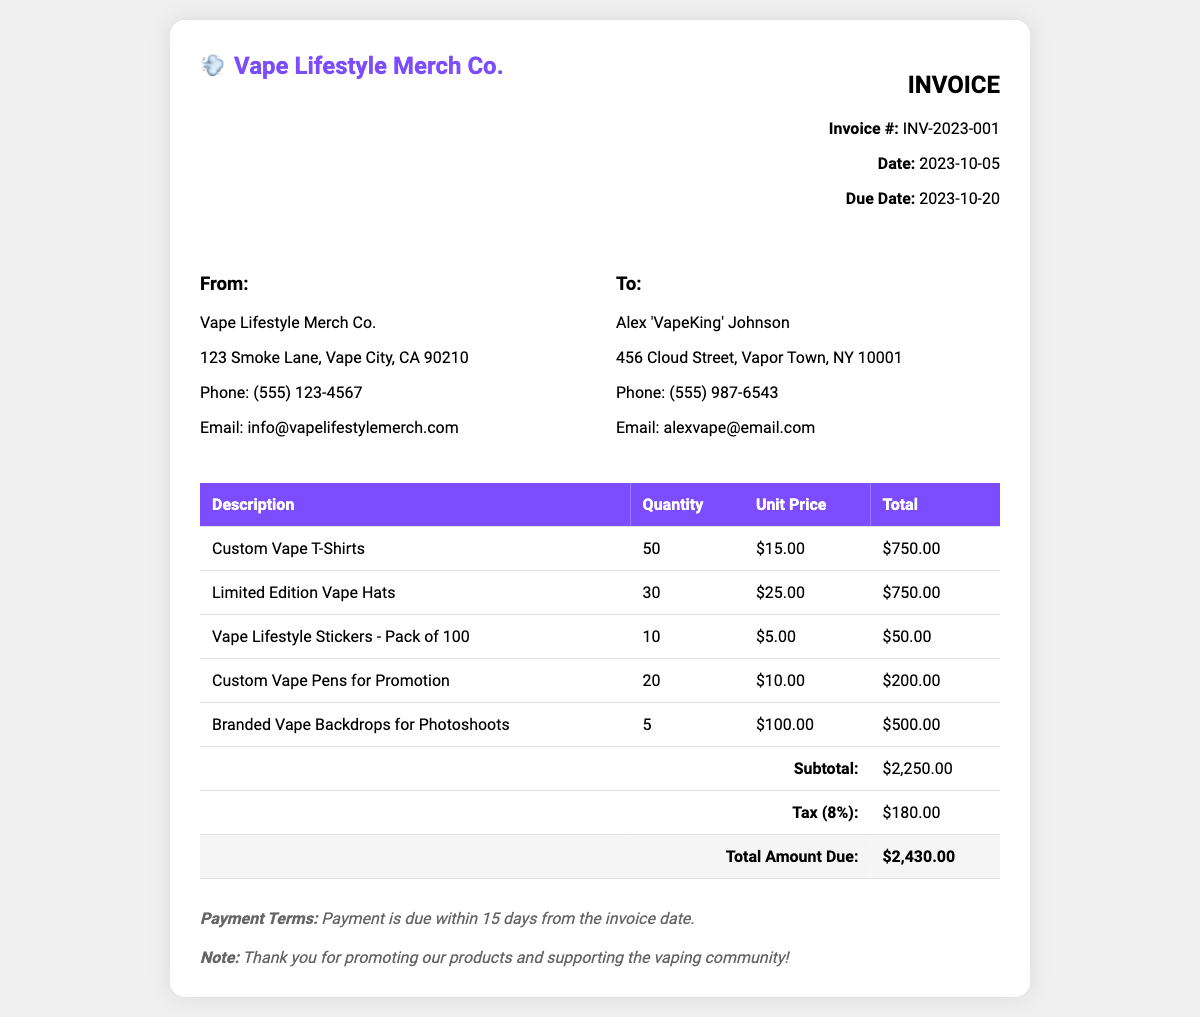What is the invoice number? The invoice number is specified at the top of the document, identified as INV-2023-001.
Answer: INV-2023-001 What is the subtotal amount? The subtotal amount is listed in the total section of the document, which shows $2,250.00.
Answer: $2,250.00 How many Custom Vape T-Shirts were ordered? The number of Custom Vape T-Shirts is found in the quantity column for that item, which shows 50.
Answer: 50 Who is the invoice addressed to? The recipient's name is located in the "To" section of the document, which identifies Alex 'VapeKing' Johnson.
Answer: Alex 'VapeKing' Johnson What is the total amount due? The total amount due can be found at the bottom of the invoice, which is stated as $2,430.00.
Answer: $2,430.00 What is the tax percentage applied? The tax percentage can be deduced from the tax amount in the document, which indicates an 8% rate.
Answer: 8% How many Limited Edition Vape Hats were ordered? The quantity of Limited Edition Vape Hats is presented in the table, which shows 30.
Answer: 30 What is the deadline for payment? The payment's due date is noted in the invoice details, specifying 2023-10-20.
Answer: 2023-10-20 What item has the highest unit price? By comparing the unit prices in the table, the item with the highest price is Branded Vape Backdrops at $100.00.
Answer: $100.00 